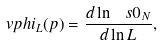<formula> <loc_0><loc_0><loc_500><loc_500>\ v p h i _ { L } ( p ) = \frac { d \ln \ s 0 _ { N } } { d \ln L } ,</formula> 